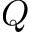<formula> <loc_0><loc_0><loc_500><loc_500>Q</formula> 